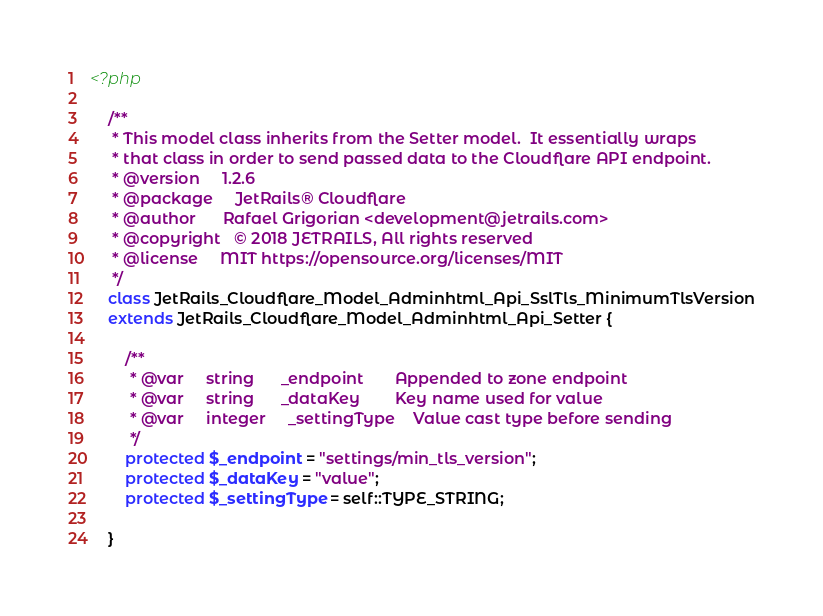<code> <loc_0><loc_0><loc_500><loc_500><_PHP_><?php

	/**
	 * This model class inherits from the Setter model.  It essentially wraps
	 * that class in order to send passed data to the Cloudflare API endpoint.
	 * @version     1.2.6
	 * @package     JetRails® Cloudflare
	 * @author      Rafael Grigorian <development@jetrails.com>
	 * @copyright   © 2018 JETRAILS, All rights reserved
	 * @license     MIT https://opensource.org/licenses/MIT
	 */
	class JetRails_Cloudflare_Model_Adminhtml_Api_SslTls_MinimumTlsVersion
	extends JetRails_Cloudflare_Model_Adminhtml_Api_Setter {

		/**
		 * @var     string      _endpoint       Appended to zone endpoint
		 * @var     string      _dataKey        Key name used for value
		 * @var     integer     _settingType    Value cast type before sending
		 */
		protected $_endpoint = "settings/min_tls_version";
		protected $_dataKey = "value";
		protected $_settingType = self::TYPE_STRING;

	}
</code> 